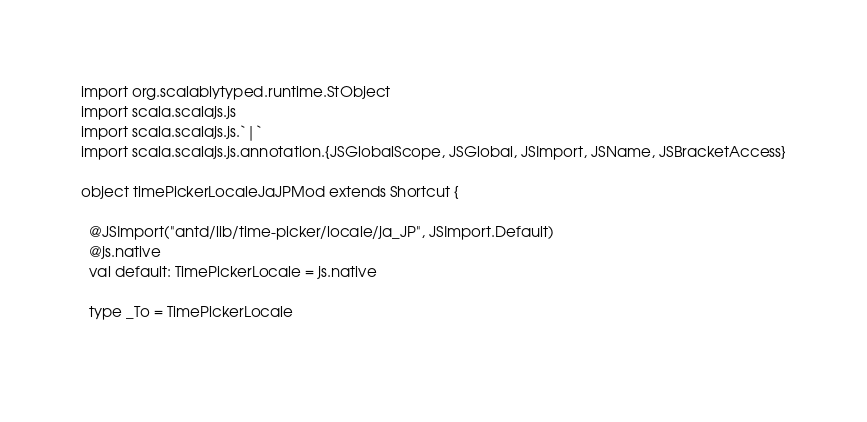<code> <loc_0><loc_0><loc_500><loc_500><_Scala_>import org.scalablytyped.runtime.StObject
import scala.scalajs.js
import scala.scalajs.js.`|`
import scala.scalajs.js.annotation.{JSGlobalScope, JSGlobal, JSImport, JSName, JSBracketAccess}

object timePickerLocaleJaJPMod extends Shortcut {
  
  @JSImport("antd/lib/time-picker/locale/ja_JP", JSImport.Default)
  @js.native
  val default: TimePickerLocale = js.native
  
  type _To = TimePickerLocale
  </code> 